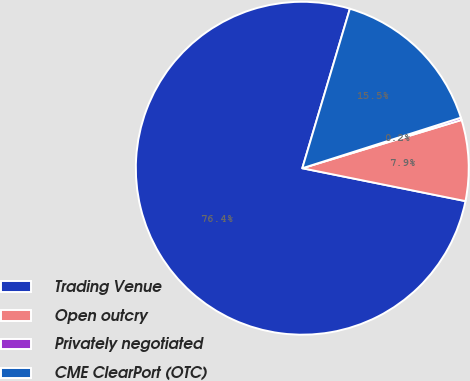Convert chart to OTSL. <chart><loc_0><loc_0><loc_500><loc_500><pie_chart><fcel>Trading Venue<fcel>Open outcry<fcel>Privately negotiated<fcel>CME ClearPort (OTC)<nl><fcel>76.45%<fcel>7.85%<fcel>0.23%<fcel>15.47%<nl></chart> 